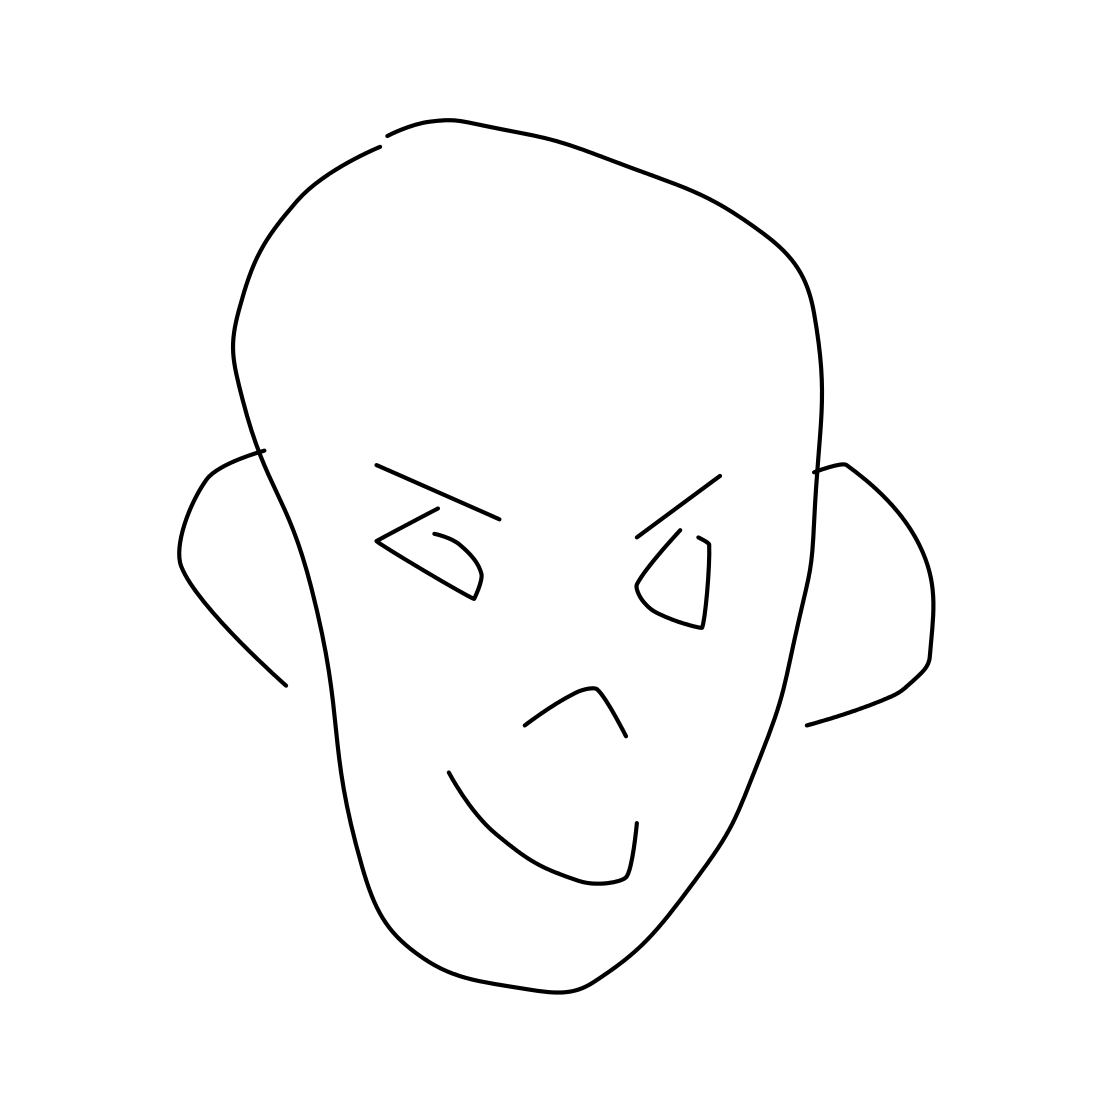Is this a head in the image? Yes, the image depicts a simple line drawing of a head with stylized features. It shows a face with eyes, a nose, and a mouth, along with the outline of the head and ears. 